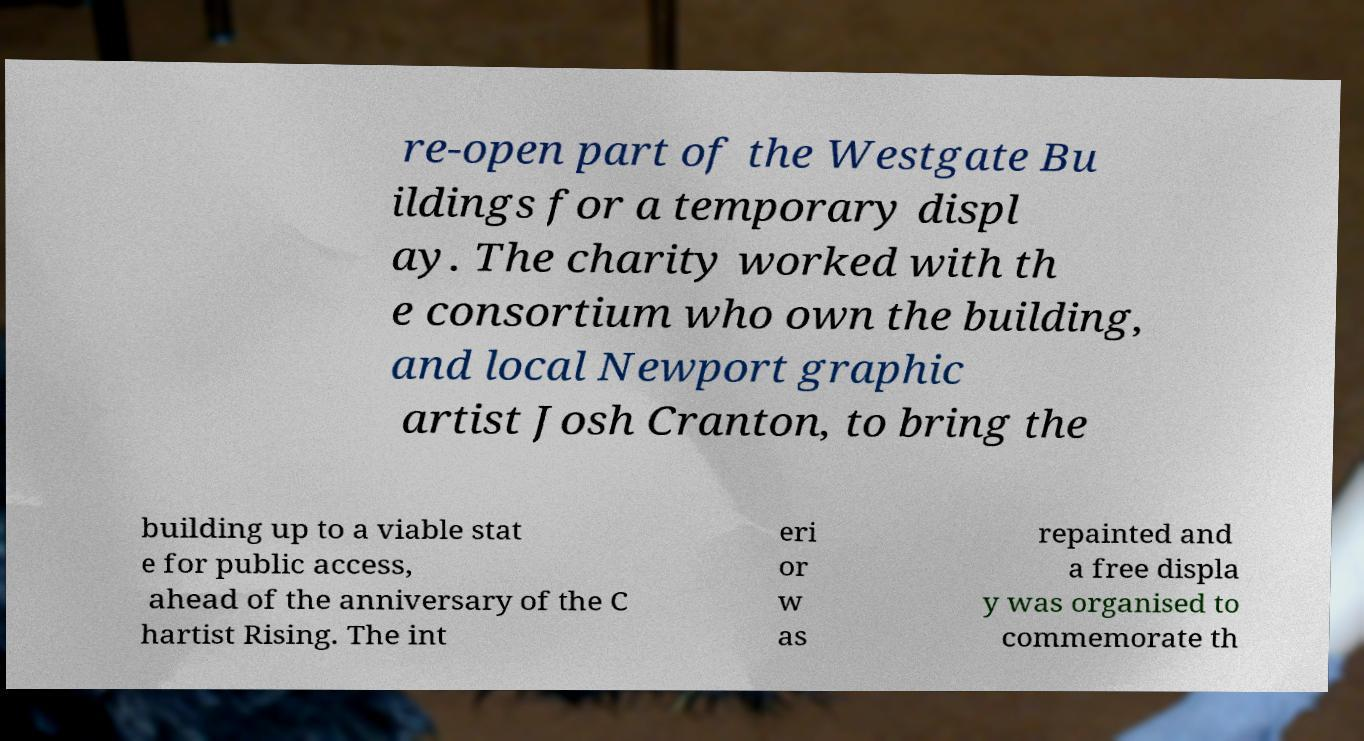There's text embedded in this image that I need extracted. Can you transcribe it verbatim? re-open part of the Westgate Bu ildings for a temporary displ ay. The charity worked with th e consortium who own the building, and local Newport graphic artist Josh Cranton, to bring the building up to a viable stat e for public access, ahead of the anniversary of the C hartist Rising. The int eri or w as repainted and a free displa y was organised to commemorate th 